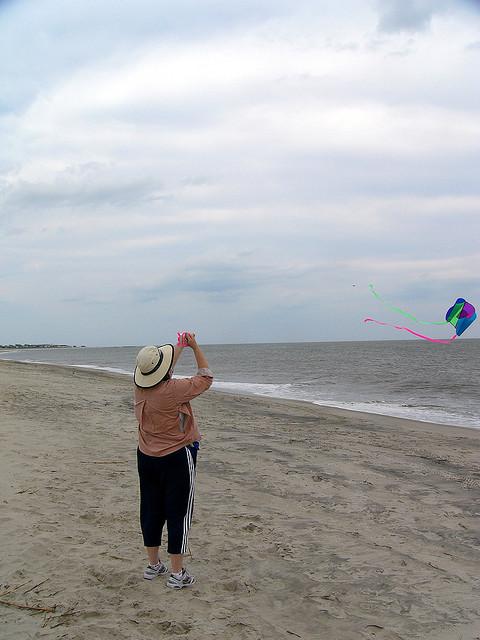What is on her head?
Concise answer only. Hat. What is she holding in her hand?
Keep it brief. Kite. What color is the hat?
Write a very short answer. White. What is in the air?
Give a very brief answer. Kite. Is she dressed for cold weather?
Be succinct. No. Is the person wearing a sun hat?
Be succinct. Yes. How many kites are flying?
Write a very short answer. 1. Are there any shadows?
Write a very short answer. No. What are these people throwing?
Answer briefly. Kite. 